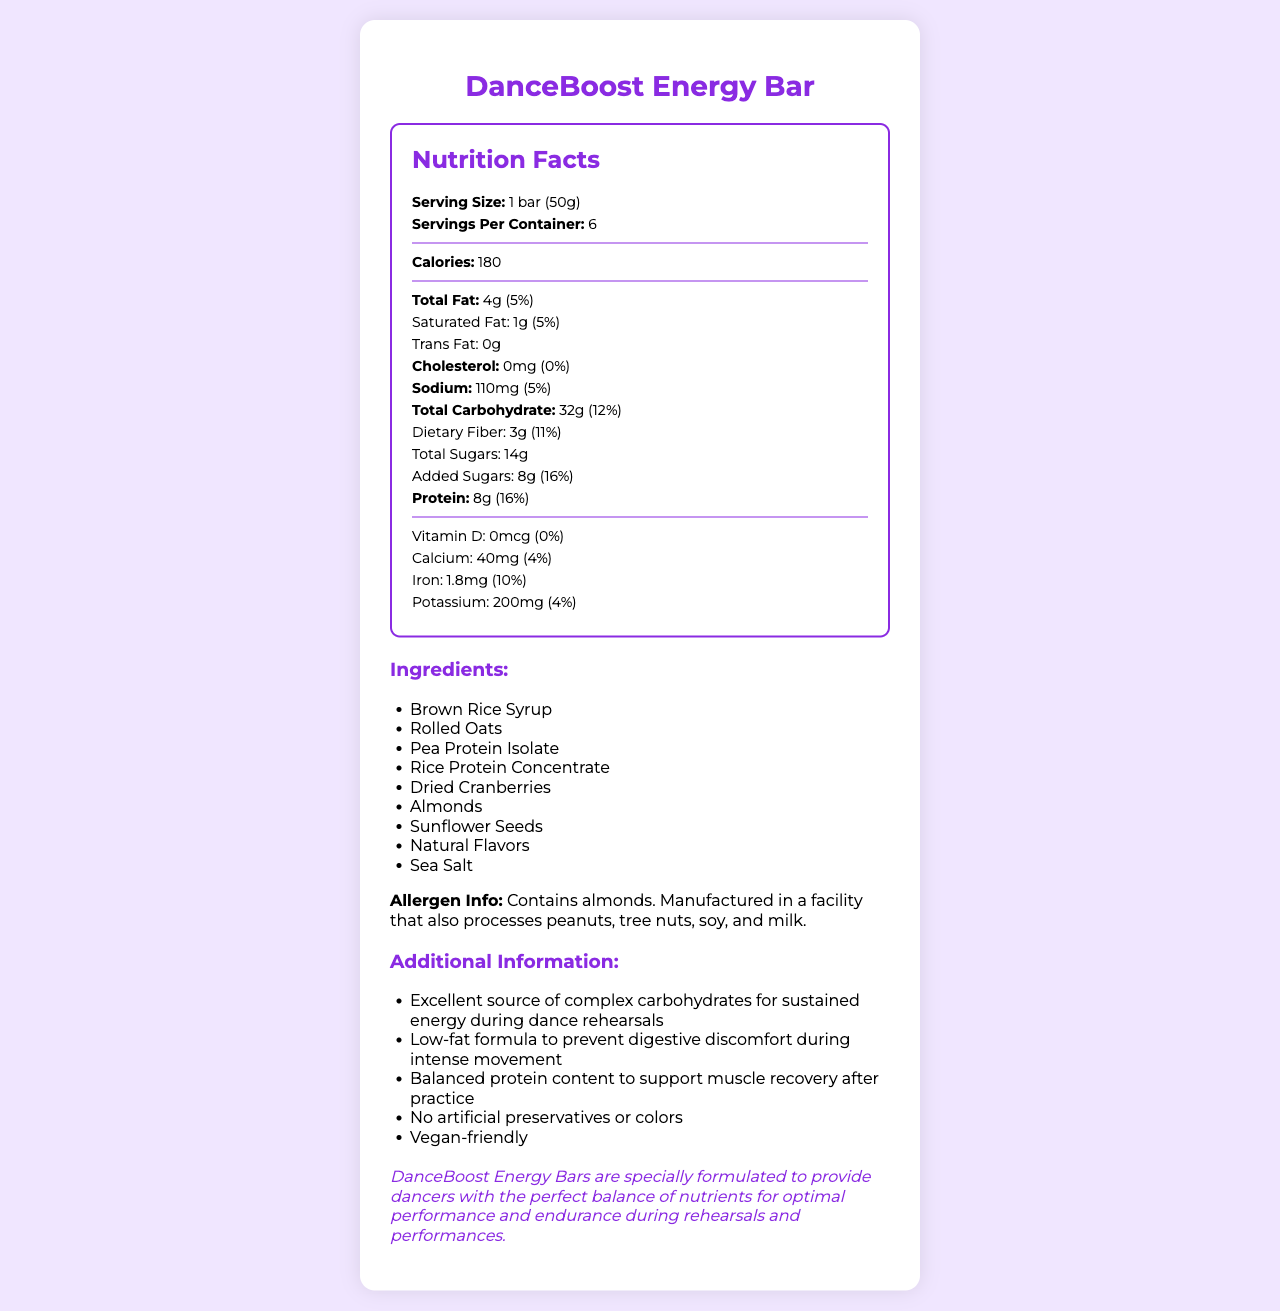what is the serving size of DanceBoost Energy Bar? The serving size is directly stated in the document as "1 bar (50g)".
Answer: 1 bar (50g) how many servings are in one container of DanceBoost Energy Bar? The document mentions that there are 6 servings per container.
Answer: 6 what is the amount of dietary fiber in one serving? The document lists 3g of dietary fiber per serving.
Answer: 3g what percentage of the daily value of protein does one serving provide? The document indicates that each serving provides 16% of the daily value for protein.
Answer: 16% what vitamin is not present in the DanceBoost Energy Bar? The document shows that Vitamin D is listed with 0mcg, meaning it is not present.
Answer: Vitamin D how many calories are there per serving? The document states that there are 180 calories per serving.
Answer: 180 how much saturated fat does one serving contain? The document shows that one serving contains 1g of saturated fat.
Answer: 1g which ingredient is not found in the DanceBoost Energy Bar? A. Brown Rice Syrup B. Rolled Oats C. Honey D. Almonds Honey is not listed among the ingredients; the listed ingredients are Brown Rice Syrup, Rolled Oats, Pea Protein Isolate, Rice Protein Concentrate, Dried Cranberries, Almonds, Sunflower Seeds, Natural Flavors, and Sea Salt.
Answer: C. Honey how much added sugars are there in one serving? The document lists that there are 8 grams of added sugars per serving.
Answer: 8g which of the following statements is true about the DanceBoost Energy Bar? I. It contains no artificial preservatives. II. It provides a quick energy release. III. It contains dairy. The document states in the additional info that the bar contains no artificial preservatives or colors and provides a quick energy release for pre-rehearsal fueling.
Answer: I and II is the DanceBoost Energy Bar vegan-friendly? The document clearly lists "Vegan-friendly" under additional information.
Answer: Yes summarize the main idea of the DanceBoost Energy Bar’s nutrition label. The document provides detailed nutritional information, ingredients, allergen info, and additional benefits designed specifically for dancers.
Answer: The DanceBoost Energy Bar is a low-fat, high-energy snack designed for dancers, with ingredients like brown rice syrup and rolled oats that provide sustained energy. It contains 180 calories per serving, with 4g total fat, 8g protein, and 32g carbohydrates. It's vegan-friendly, has no artificial preservatives or colors, and supports muscle recovery and optimal performance during dance rehearsals. Allergens include almonds, and it is manufactured in a facility that processes other allergens. how many grams of total sugars are included in DanceBoost Energy Bar? The document indicates that there are 14 grams of total sugars.
Answer: 14g what is the amount of iron provided per serving of this energy bar? The document lists that each serving provides 1.8mg of iron.
Answer: 1.8mg can you list any three ingredients in this energy bar? These ingredients are listed in the ingredients section of the document.
Answer: Brown Rice Syrup, Rolled Oats, Pea Protein Isolate does the document mention the manufacturing facility also processes peanuts? The allergen information section in the document mentions that the manufacturing facility also processes peanuts.
Answer: Yes from the document, what is the main benefit of the protein content in the DanceBoost Energy Bar? The document explains that the balanced protein content supports muscle recovery after practice.
Answer: Supports muscle recovery what is the total fat content in one serving of DanceBoost Energy Bar? The document explicitly states that the total fat content per serving is 4g.
Answer: 4g what is the brand statement of DanceBoost Energy Bar? This is stated in the brand statement section of the document.
Answer: DanceBoost Energy Bars are specially formulated to provide dancers with the perfect balance of nutrients for optimal performance and endurance during rehearsals and performances. which nutrients have a daily value percentage of 0%? The document lists both cholesterol and vitamin D with a daily value percentage of 0%.
Answer: Cholesterol, Vitamin D what kind of carbohydrate is DanceBoost Energy Bar an excellent source of, according to the document? The document's additional information section lists that the energy bar is an excellent source of complex carbohydrates for sustained energy.
Answer: Complex carbohydrates does the DanceBoost Energy Bar contain peanuts? The document states that it is manufactured in a facility that processes peanuts, but it does not confirm if peanuts are an ingredient.
Answer: Cannot be determined 